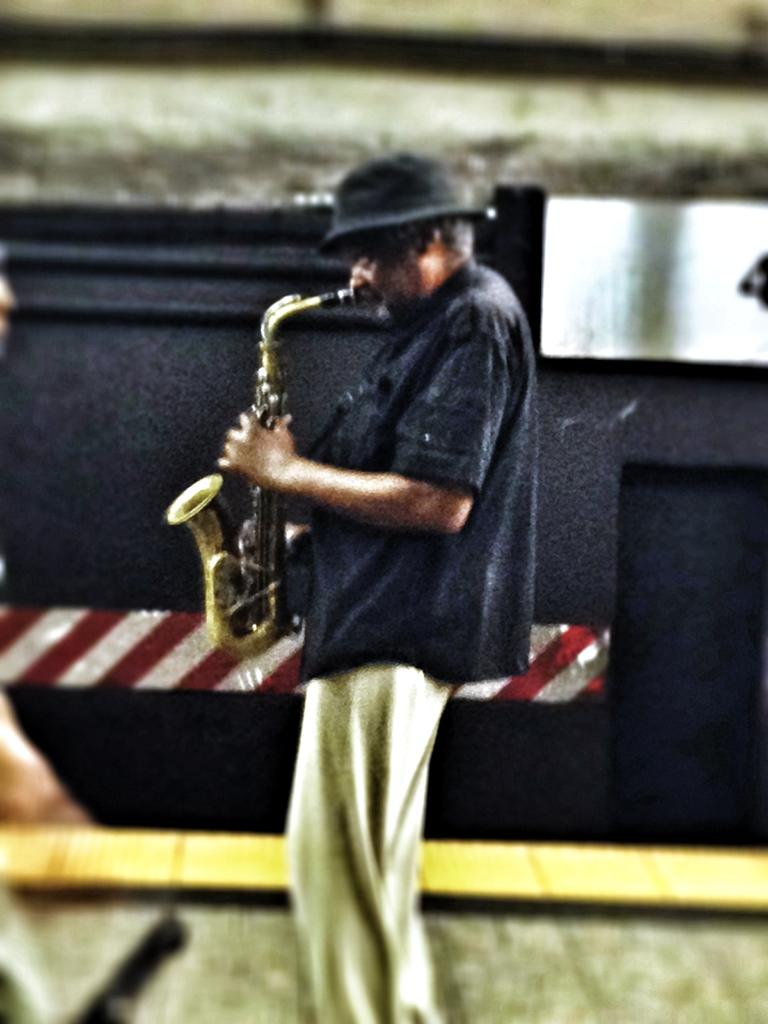What is the main subject of the image? There is a person in the image. What is the person wearing on his upper body? The person is wearing a black color shirt. What is on the person's head? The person is wearing a hat. What is the person doing in the image? The person is playing a trumpet. What color is the wall in the background of the image? The wall in the background of the image is black color. Is the toy on fire in the image? There is no toy present in the image, and therefore it cannot be on fire. Can you tell me how many chairs are visible in the image? There are no chairs visible in the image. 